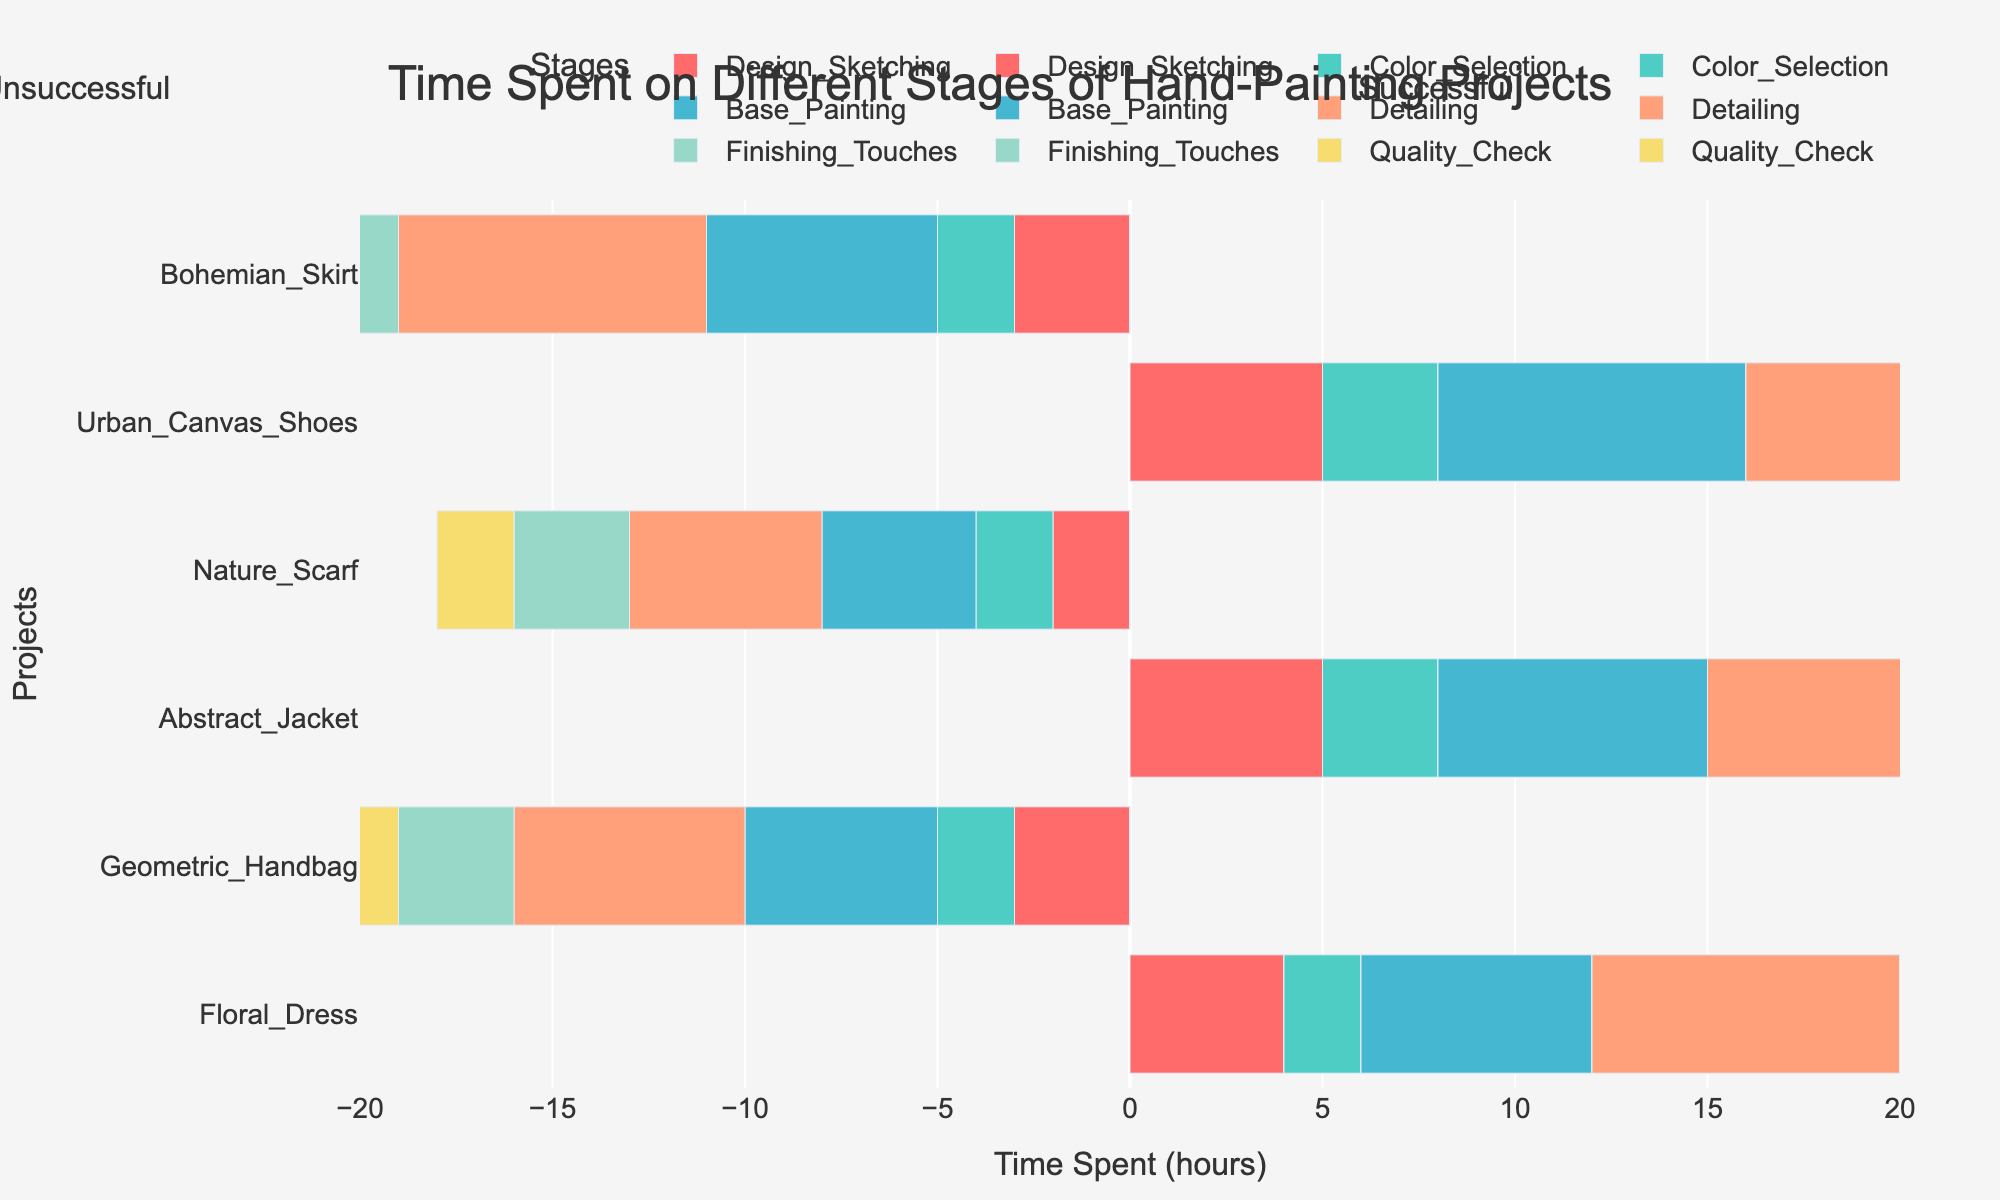What is the total time spent on successful projects during the Design Sketching stage? To find the total time spent on successful projects during the Design Sketching stage, sum up the hours for all successful projects in this stage. The successful projects and their times are: Floral Dress (4), Abstract Jacket (5), Urban Canvas Shoes (5). Thus, the total time is 4 + 5 + 5 = 14 hours.
Answer: 14 hours Which stage is most time-consuming on unsuccessful projects? Compare the total time spent on each stage across all unsuccessful projects. Summing up the times for unsuccessful projects: Design Sketching (3 + 2 + 3), Color Selection (2 + 2 + 2), Base Painting (5 + 4 + 6), Detailing (6 + 5 + 8), Finishing Touches (3 + 3 + 4), Quality Check (5 + 2 + 3). Detailing sums to 6 + 5 + 8 = 19 hours, which is the highest.
Answer: Detailing How does the time spent on Quality Check compare between the successful and unsuccessful projects? Sum the time spent on Quality Check separately for successful and unsuccessful projects. Successful projects: Floral Dress (2), Abstract Jacket (3), Urban Canvas Shoes (3) total to 2 + 3 + 3 = 8 hours. Unsuccessful projects: Geometric Handbag (5), Nature Scarf (2), Bohemian Skirt (3) total to 5 + 2 + 3 = 10 hours. Compare 8 hours vs 10 hours.
Answer: 8 hours (successful) is less than 10 hours (unsuccessful) What is the average time spent on Base Painting across all projects? Sum the time spent on Base Painting for all projects and then divide by the number of projects. Time spent: Floral Dress (6), Geometric Handbag (5), Abstract Jacket (7), Nature Scarf (4), Urban Canvas Shoes (8), Bohemian Skirt (6). Sum is 6 + 5 + 7 + 4 + 8 + 6 = 36. There are 6 projects, so the average is 36/6 = 6 hours.
Answer: 6 hours In the stage of Finishing Touches, how many more hours are spent on successful projects compared to unsuccessful ones? Sum the Finishing Touches time for successful and unsuccessful projects separately. Successful: Floral Dress (4), Abstract Jacket (4), Urban Canvas Shoes (5) total to 4 + 4 + 5 = 13 hours. Unsuccessful: Geometric Handbag (3), Nature Scarf (3), Bohemian Skirt (4) total to 3 + 3 + 4 = 10 hours. Difference is 13 - 10 = 3 hours.
Answer: 3 hours Identify which project has the maximum time spent on any single stage, and specify the stage and outcome. Check the time spent on each stage for all projects and identify the maximum value. The entries are: Detailing Urban Canvas Shoes (10 hours). This is the maximum time spent on any single stage. This stage is part of a successful project.
Answer: Urban Canvas Shoes, Detailing, Successful What is the ratio of total time spent on successful projects to unsuccessful projects? First, sum the time spent on all stages for successful and unsuccessful projects separately. Successful: (4+2+6+8+4+2) + (5+3+7+9+4+3) + (5+3+8+10+5+3) = 26 + 31 + 34 = 91 hours. Unsuccessful: (3+2+5+6+3+5) + (2+2+4+5+3+2) + (3+2+6+8+4+3) = 24 + 18 + 26 = 68 hours. The ratio is 91:68.
Answer: 91:68 Is there any stage where the total time spent on successful projects perfectly matches the total time spent on unsuccessful projects? For each stage, compare the total time spent on successful and unsuccessful projects. Summing the times: Design Sketching (successful: 4+5+5=14, unsuccessful: 3+2+3=8), Color Selection (successful: 2+3+3=8, unsuccessful: 2+2+2=6), Base Painting (successful: 6+7+8=21, unsuccessful: 5+4+6=15), Detailing (successful: 8+9+10=27, unsuccessful: 6+5+8=19), Finishing Touches (successful: 4+4+5=13, unsuccessful: 3+3+4=10), Quality Check (successful: 2+3+3=8, unsuccessful: 5+2+3=10). No stage matches perfectly.
Answer: No 